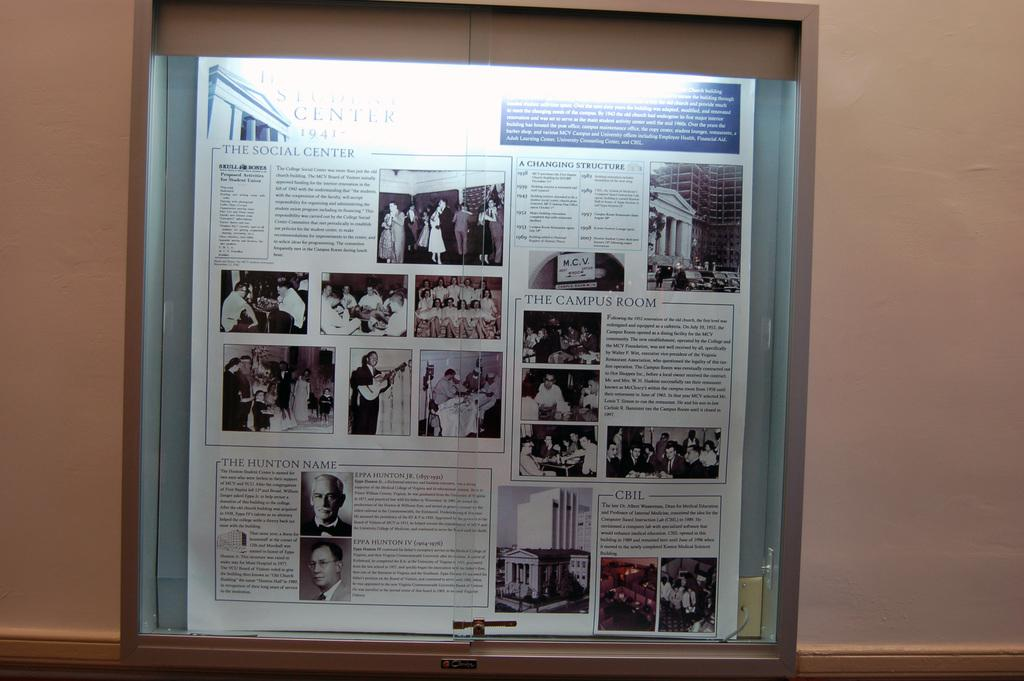<image>
Present a compact description of the photo's key features. A bulletin board displays information about a student center. 